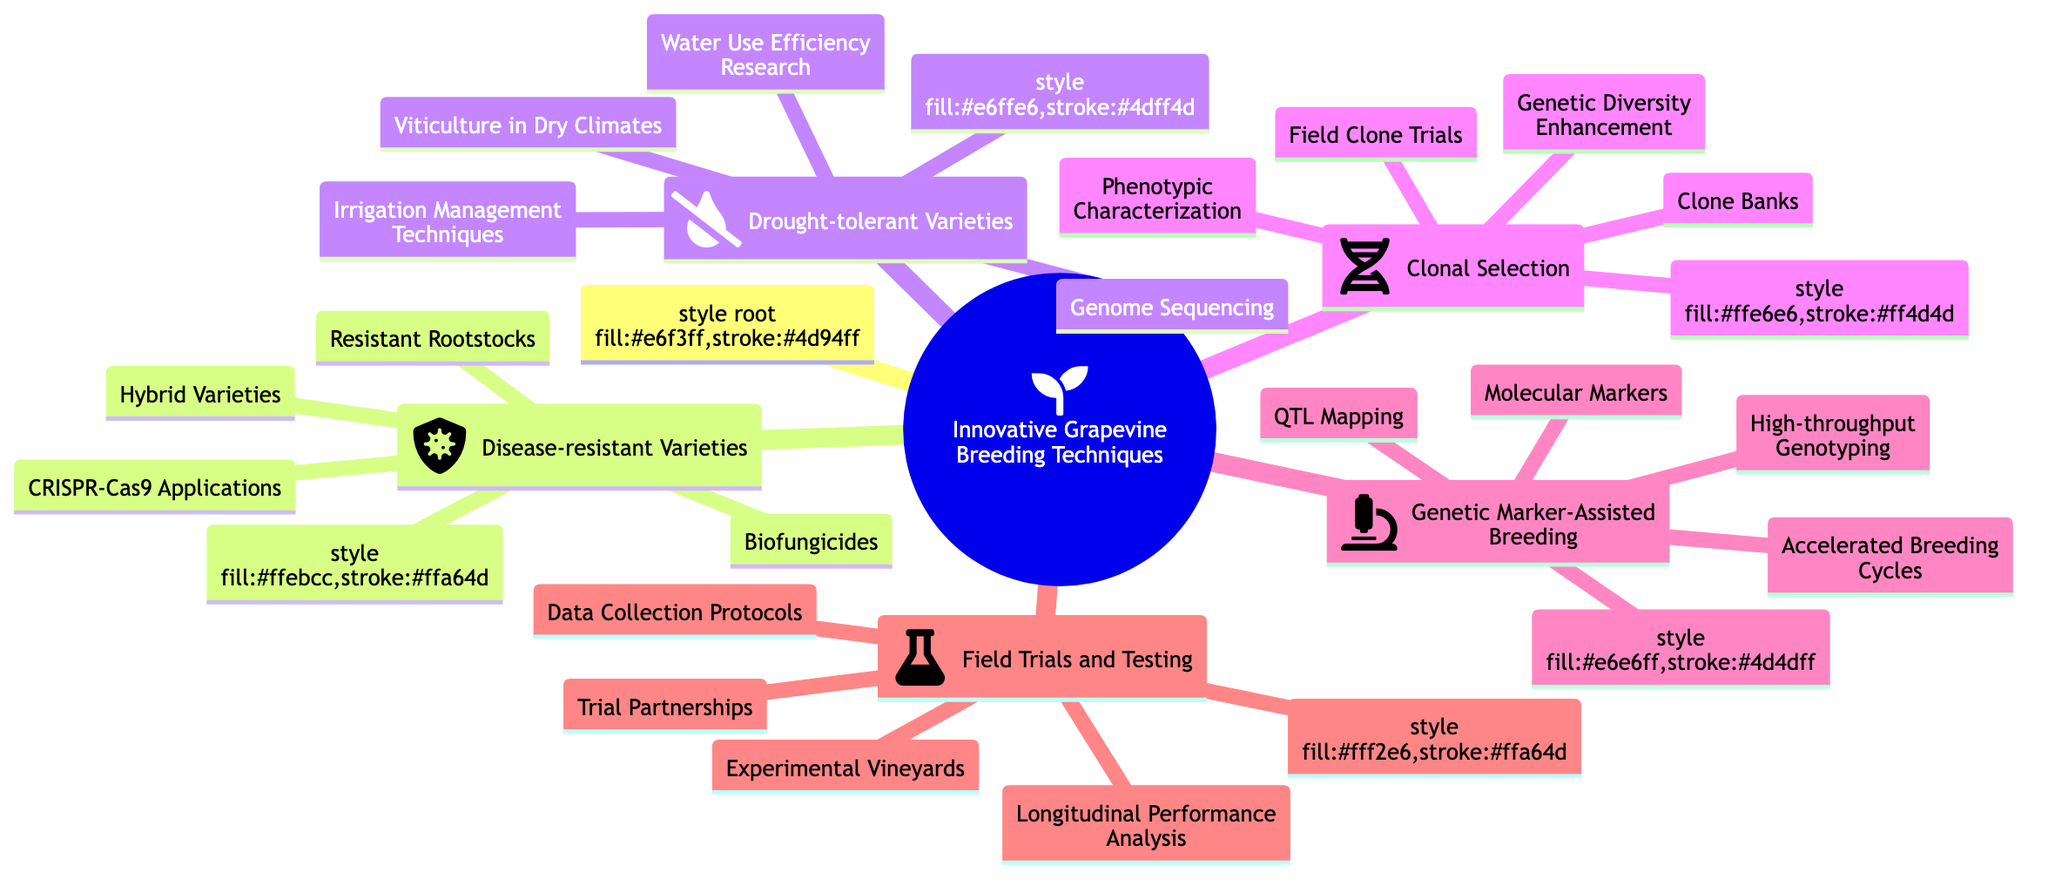What are the four main categories under Innovative Grapevine Breeding Techniques? The diagram lists five categories: Disease-resistant Varieties, Drought-tolerant Varieties, Clonal Selection, Genetic Marker-Assisted Breeding, and Field Trials and Testing.
Answer: Disease-resistant Varieties, Drought-tolerant Varieties, Clonal Selection, Genetic Marker-Assisted Breeding, Field Trials and Testing How many entities are listed under Drought-tolerant Varieties? The Drought-tolerant Varieties section contains four entities: Viticulture in Dry Climates, Genome Sequencing of Drought-resistant Grapes, Water Use Efficiency Research, and Irrigation Management Techniques.
Answer: 4 What specific technique is mentioned under Disease-resistant Varieties that involves genetic technology? The diagram specifies CRISPR-Cas9 Applications as a genetic technology technique under the Disease-resistant Varieties category.
Answer: CRISPR-Cas9 Applications Which category includes Experimental Vineyards? Experimental Vineyards is listed as an entity under the Field Trials and Testing category.
Answer: Field Trials and Testing What technique relates entities from both Disease-resistant Varieties and Drought-tolerant Varieties? Biofungicides from Disease-resistant Varieties can complement irrigation practices from Drought-tolerant Varieties, suggesting an integrated pest management approach. However, these do not directly share a single categorized technique in the mind map but are both essential for sustainable practices.
Answer: Integrated Pest Management How many entities fall under Genetic Marker-Assisted Breeding? The Genetic Marker-Assisted Breeding section details four entities: Molecular Markers, QTL Mapping, High-throughput Genotyping, and Accelerated Breeding Cycles.
Answer: 4 Which two categories focus on specific environmental challenges? The categories focusing on environmental challenges are Disease-resistant Varieties (pest and disease resistance) and Drought-tolerant Varieties (water scarcity and drought conditions).
Answer: Environmental Challenges What is the primary objective of Clonal Selection? Clonal Selection aims to enhance genetic diversity and identify superior clones for breeding, ensuring better quality and resilience in grapevines.
Answer: Genetic Diversity Enhancement What type of partnerships are highlighted in the Field Trials and Testing category? The Field Trials and Testing category highlights Trial Partnerships, specifically mentioning University Collaborations as a way to enhance research and development.
Answer: Trial Partnerships 